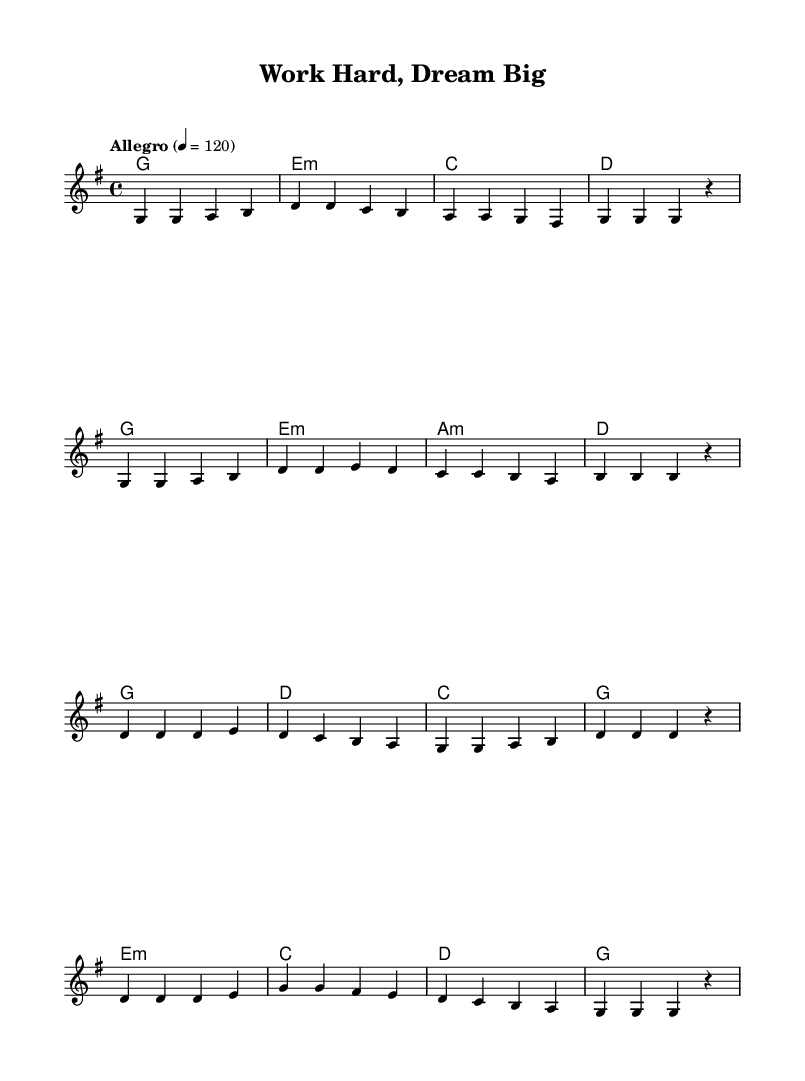What is the key signature of this music? The key signature is G major, which has one sharp (F sharp). This can be identified by looking at the leftmost side of the staff, where the key signature is indicated.
Answer: G major What is the time signature of this piece? The time signature is 4/4, meaning there are four beats in each measure and the quarter note gets one beat. This is visible in the beginning of the music notation at the start of the piece.
Answer: 4/4 What is the tempo marking for the music? The tempo marking is Allegro, which indicates a fast and lively tempo. This is stated at the beginning of the score after the key and time signature but before the melody.
Answer: Allegro How many measures are in the verse section? There are eight measures in the verse section. By counting the group of notes separated by vertical lines (bar lines), we can see that there are eight distinct segments in the verse.
Answer: Eight What is the primary theme addressed in the lyrics of this song? The primary theme is hard work and perseverance. Since this is a K-Pop song, the title "Work Hard, Dream Big" suggests a motivational message centered around traditional work ethic, which is a common theme in K-Pop lyrics.
Answer: Hard work How does the harmony progress in the chorus compared to the verse? The harmony in the chorus features a repetition of the G and D chords, creating a strong resolution, while the verse has a more varied progression including Em and Am chords. This is evident by examining the chord symbols beneath the melody in both sections, indicating the harmonic structure directly supports the melodic line.
Answer: Repetition What is a common feature of K-Pop music found in this piece? A common feature is the upbeat tempo paired with a catchy melody. This piece is marked "Allegro" in tempo, which is typical in K-Pop to maintain high energy and appeal. Additionally, the melody's simplicity and repetitiveness help to stay memorable, embodying a hallmark of K-Pop composition.
Answer: Upbeat tempo 